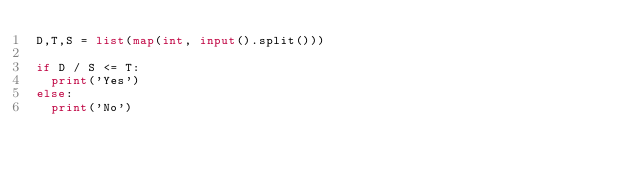<code> <loc_0><loc_0><loc_500><loc_500><_Python_>D,T,S = list(map(int, input().split()))

if D / S <= T:
  print('Yes')
else:
  print('No')</code> 